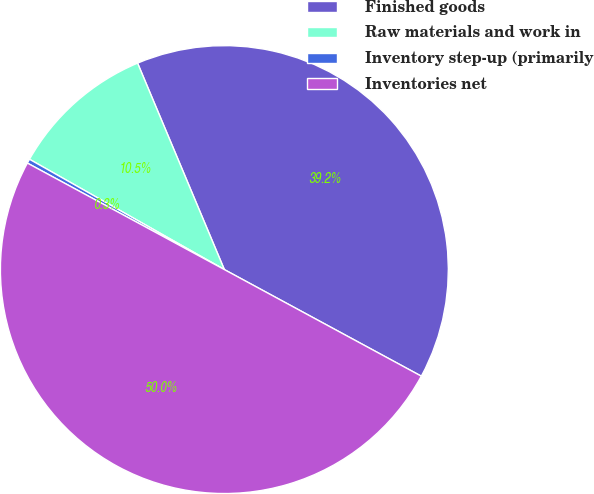Convert chart to OTSL. <chart><loc_0><loc_0><loc_500><loc_500><pie_chart><fcel>Finished goods<fcel>Raw materials and work in<fcel>Inventory step-up (primarily<fcel>Inventories net<nl><fcel>39.23%<fcel>10.47%<fcel>0.31%<fcel>50.0%<nl></chart> 